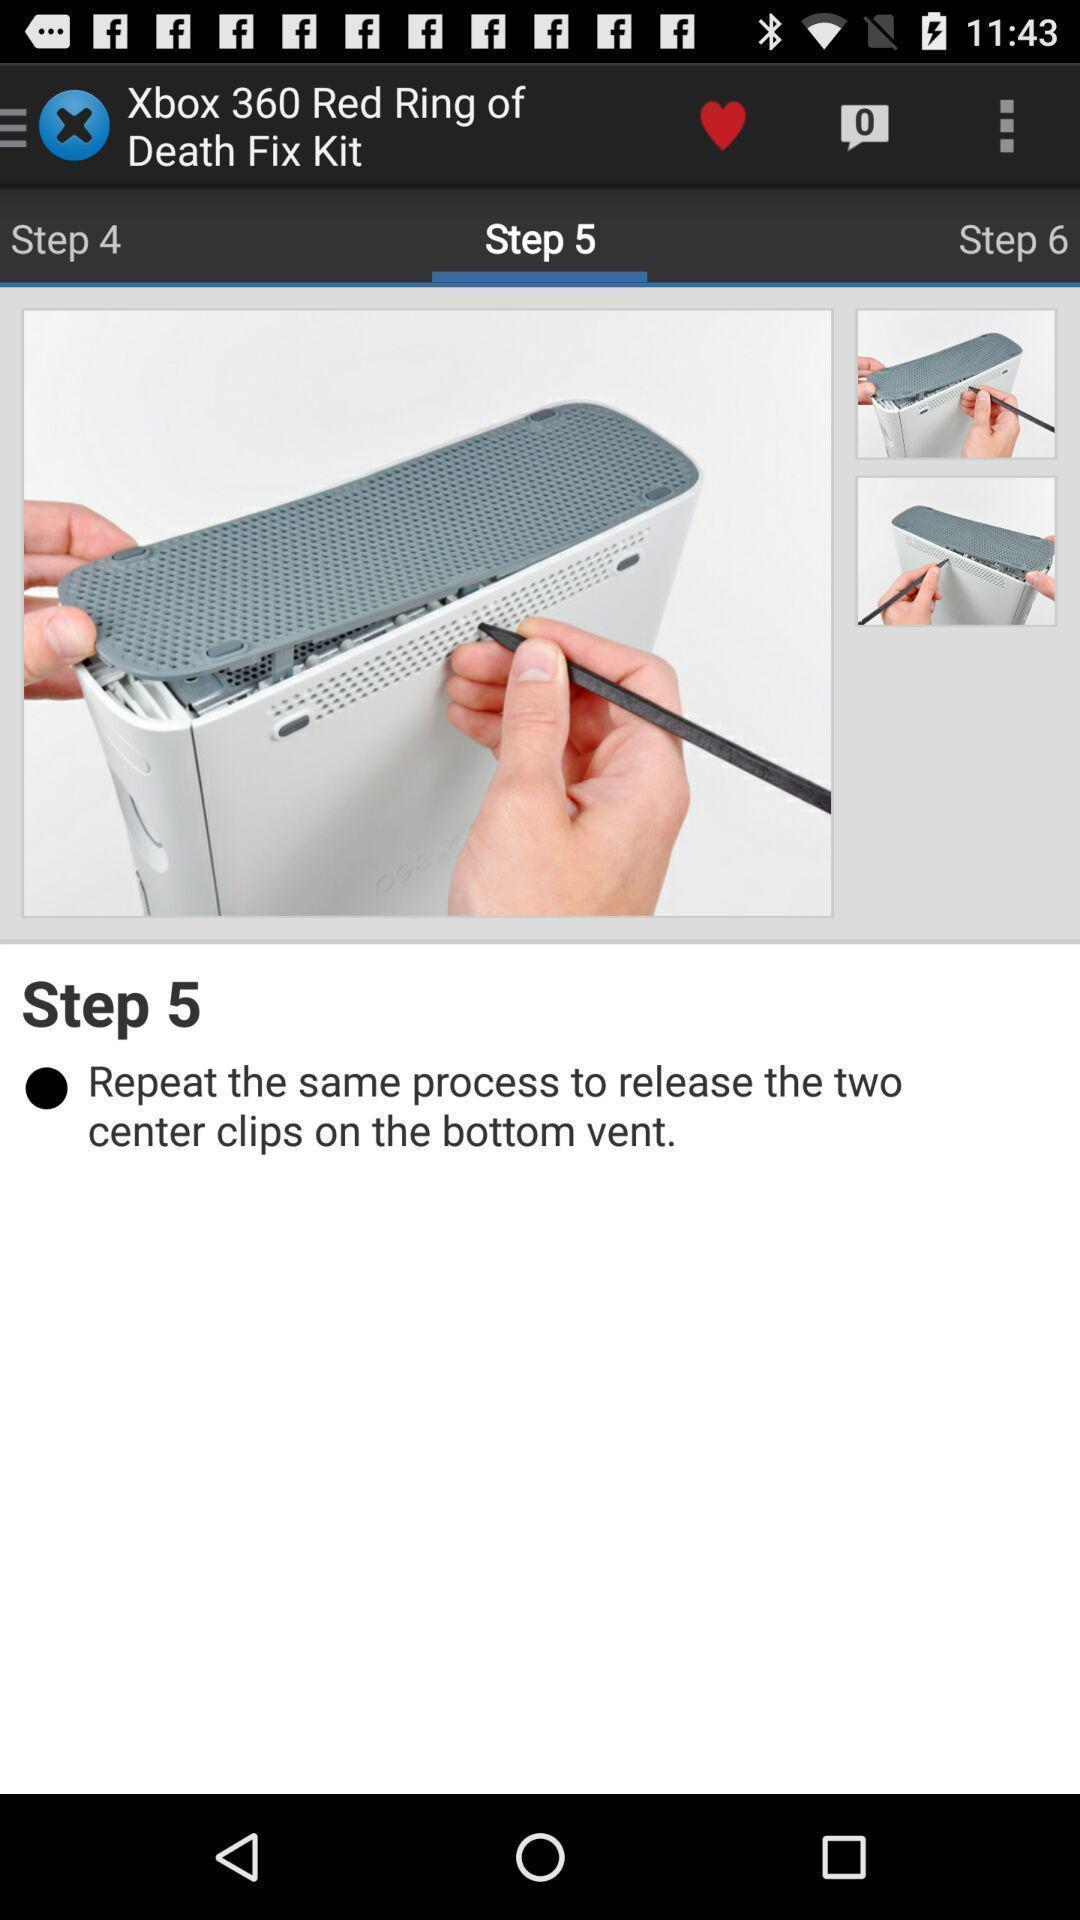Describe the content in this image. Page showing step 5 to complete the process. 